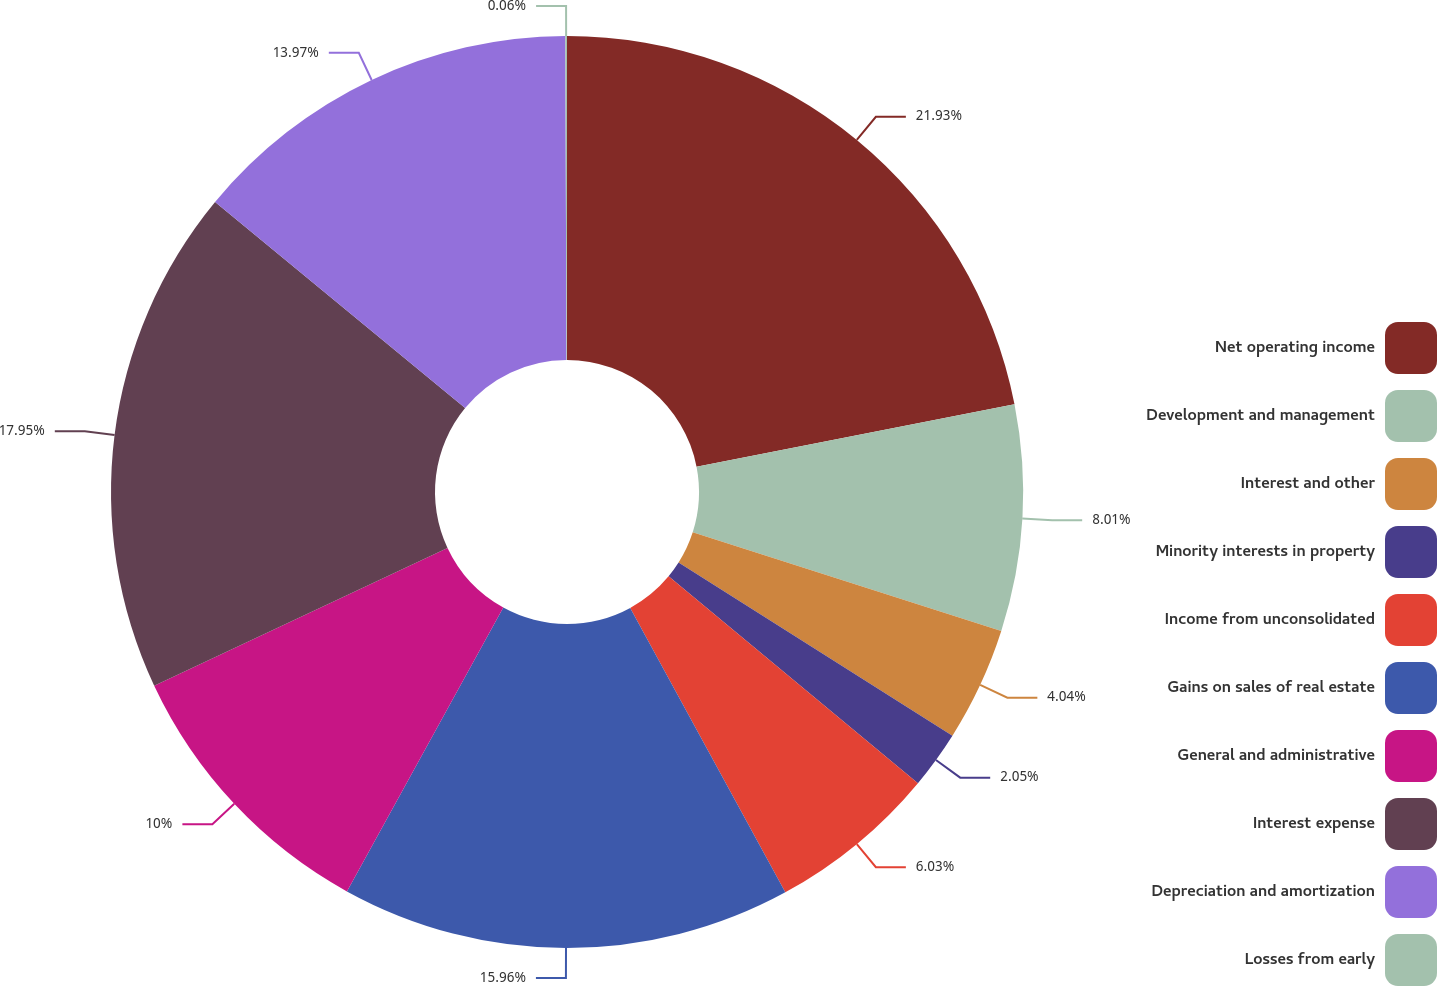<chart> <loc_0><loc_0><loc_500><loc_500><pie_chart><fcel>Net operating income<fcel>Development and management<fcel>Interest and other<fcel>Minority interests in property<fcel>Income from unconsolidated<fcel>Gains on sales of real estate<fcel>General and administrative<fcel>Interest expense<fcel>Depreciation and amortization<fcel>Losses from early<nl><fcel>21.92%<fcel>8.01%<fcel>4.04%<fcel>2.05%<fcel>6.03%<fcel>15.96%<fcel>10.0%<fcel>17.95%<fcel>13.97%<fcel>0.06%<nl></chart> 